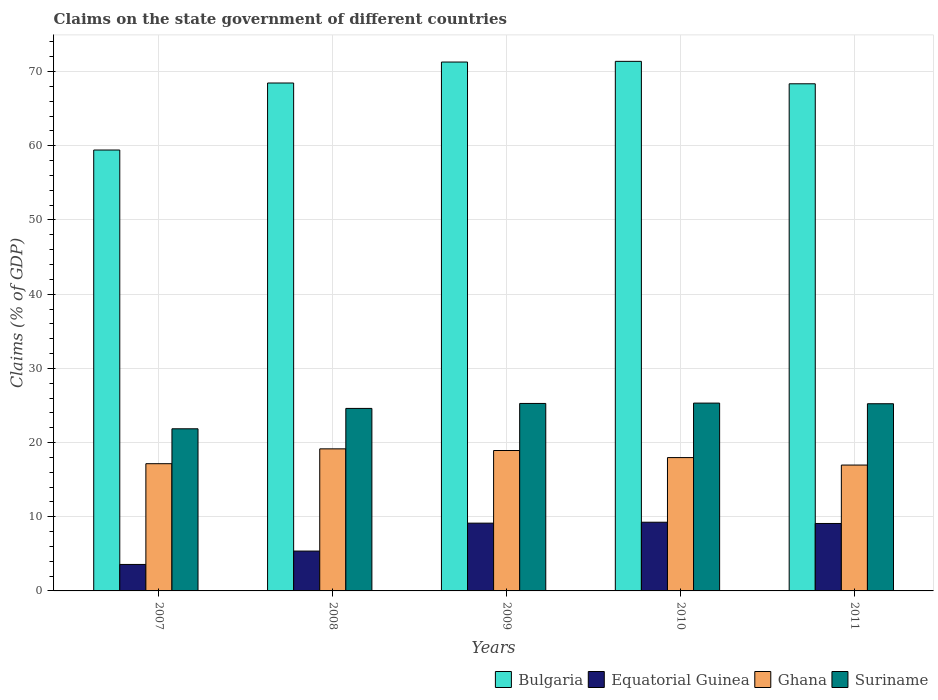How many groups of bars are there?
Your response must be concise. 5. Are the number of bars on each tick of the X-axis equal?
Provide a succinct answer. Yes. How many bars are there on the 2nd tick from the left?
Ensure brevity in your answer.  4. How many bars are there on the 3rd tick from the right?
Your answer should be very brief. 4. What is the label of the 4th group of bars from the left?
Give a very brief answer. 2010. What is the percentage of GDP claimed on the state government in Ghana in 2008?
Keep it short and to the point. 19.15. Across all years, what is the maximum percentage of GDP claimed on the state government in Suriname?
Offer a very short reply. 25.32. Across all years, what is the minimum percentage of GDP claimed on the state government in Suriname?
Your response must be concise. 21.85. What is the total percentage of GDP claimed on the state government in Bulgaria in the graph?
Offer a terse response. 338.93. What is the difference between the percentage of GDP claimed on the state government in Ghana in 2007 and that in 2010?
Your answer should be compact. -0.82. What is the difference between the percentage of GDP claimed on the state government in Ghana in 2010 and the percentage of GDP claimed on the state government in Suriname in 2009?
Your answer should be compact. -7.3. What is the average percentage of GDP claimed on the state government in Ghana per year?
Your answer should be compact. 18.03. In the year 2008, what is the difference between the percentage of GDP claimed on the state government in Equatorial Guinea and percentage of GDP claimed on the state government in Bulgaria?
Ensure brevity in your answer.  -63.09. What is the ratio of the percentage of GDP claimed on the state government in Suriname in 2007 to that in 2008?
Offer a very short reply. 0.89. Is the percentage of GDP claimed on the state government in Suriname in 2007 less than that in 2009?
Your answer should be very brief. Yes. What is the difference between the highest and the second highest percentage of GDP claimed on the state government in Ghana?
Keep it short and to the point. 0.22. What is the difference between the highest and the lowest percentage of GDP claimed on the state government in Equatorial Guinea?
Provide a succinct answer. 5.69. Is the sum of the percentage of GDP claimed on the state government in Equatorial Guinea in 2010 and 2011 greater than the maximum percentage of GDP claimed on the state government in Ghana across all years?
Provide a succinct answer. No. What does the 1st bar from the left in 2010 represents?
Ensure brevity in your answer.  Bulgaria. What does the 4th bar from the right in 2009 represents?
Ensure brevity in your answer.  Bulgaria. How many bars are there?
Ensure brevity in your answer.  20. Where does the legend appear in the graph?
Keep it short and to the point. Bottom right. What is the title of the graph?
Your answer should be compact. Claims on the state government of different countries. What is the label or title of the Y-axis?
Provide a short and direct response. Claims (% of GDP). What is the Claims (% of GDP) in Bulgaria in 2007?
Your answer should be very brief. 59.43. What is the Claims (% of GDP) of Equatorial Guinea in 2007?
Provide a succinct answer. 3.57. What is the Claims (% of GDP) of Ghana in 2007?
Ensure brevity in your answer.  17.15. What is the Claims (% of GDP) of Suriname in 2007?
Provide a short and direct response. 21.85. What is the Claims (% of GDP) in Bulgaria in 2008?
Offer a terse response. 68.46. What is the Claims (% of GDP) in Equatorial Guinea in 2008?
Offer a very short reply. 5.37. What is the Claims (% of GDP) of Ghana in 2008?
Your answer should be very brief. 19.15. What is the Claims (% of GDP) in Suriname in 2008?
Give a very brief answer. 24.6. What is the Claims (% of GDP) in Bulgaria in 2009?
Your answer should be compact. 71.29. What is the Claims (% of GDP) of Equatorial Guinea in 2009?
Your answer should be compact. 9.13. What is the Claims (% of GDP) of Ghana in 2009?
Keep it short and to the point. 18.93. What is the Claims (% of GDP) in Suriname in 2009?
Offer a terse response. 25.27. What is the Claims (% of GDP) in Bulgaria in 2010?
Keep it short and to the point. 71.38. What is the Claims (% of GDP) in Equatorial Guinea in 2010?
Offer a terse response. 9.26. What is the Claims (% of GDP) in Ghana in 2010?
Your answer should be very brief. 17.97. What is the Claims (% of GDP) in Suriname in 2010?
Give a very brief answer. 25.32. What is the Claims (% of GDP) in Bulgaria in 2011?
Give a very brief answer. 68.36. What is the Claims (% of GDP) in Equatorial Guinea in 2011?
Give a very brief answer. 9.09. What is the Claims (% of GDP) of Ghana in 2011?
Your answer should be very brief. 16.97. What is the Claims (% of GDP) in Suriname in 2011?
Give a very brief answer. 25.23. Across all years, what is the maximum Claims (% of GDP) in Bulgaria?
Give a very brief answer. 71.38. Across all years, what is the maximum Claims (% of GDP) in Equatorial Guinea?
Provide a short and direct response. 9.26. Across all years, what is the maximum Claims (% of GDP) of Ghana?
Offer a very short reply. 19.15. Across all years, what is the maximum Claims (% of GDP) of Suriname?
Your answer should be compact. 25.32. Across all years, what is the minimum Claims (% of GDP) of Bulgaria?
Ensure brevity in your answer.  59.43. Across all years, what is the minimum Claims (% of GDP) in Equatorial Guinea?
Make the answer very short. 3.57. Across all years, what is the minimum Claims (% of GDP) in Ghana?
Your answer should be compact. 16.97. Across all years, what is the minimum Claims (% of GDP) of Suriname?
Offer a terse response. 21.85. What is the total Claims (% of GDP) in Bulgaria in the graph?
Provide a succinct answer. 338.93. What is the total Claims (% of GDP) in Equatorial Guinea in the graph?
Provide a short and direct response. 36.43. What is the total Claims (% of GDP) of Ghana in the graph?
Provide a short and direct response. 90.17. What is the total Claims (% of GDP) in Suriname in the graph?
Give a very brief answer. 122.27. What is the difference between the Claims (% of GDP) in Bulgaria in 2007 and that in 2008?
Offer a terse response. -9.03. What is the difference between the Claims (% of GDP) of Equatorial Guinea in 2007 and that in 2008?
Make the answer very short. -1.8. What is the difference between the Claims (% of GDP) of Ghana in 2007 and that in 2008?
Offer a terse response. -2. What is the difference between the Claims (% of GDP) of Suriname in 2007 and that in 2008?
Offer a very short reply. -2.75. What is the difference between the Claims (% of GDP) in Bulgaria in 2007 and that in 2009?
Ensure brevity in your answer.  -11.86. What is the difference between the Claims (% of GDP) in Equatorial Guinea in 2007 and that in 2009?
Make the answer very short. -5.57. What is the difference between the Claims (% of GDP) of Ghana in 2007 and that in 2009?
Give a very brief answer. -1.78. What is the difference between the Claims (% of GDP) of Suriname in 2007 and that in 2009?
Your answer should be compact. -3.42. What is the difference between the Claims (% of GDP) of Bulgaria in 2007 and that in 2010?
Your response must be concise. -11.95. What is the difference between the Claims (% of GDP) in Equatorial Guinea in 2007 and that in 2010?
Your answer should be very brief. -5.69. What is the difference between the Claims (% of GDP) in Ghana in 2007 and that in 2010?
Keep it short and to the point. -0.82. What is the difference between the Claims (% of GDP) in Suriname in 2007 and that in 2010?
Offer a very short reply. -3.46. What is the difference between the Claims (% of GDP) of Bulgaria in 2007 and that in 2011?
Offer a terse response. -8.93. What is the difference between the Claims (% of GDP) in Equatorial Guinea in 2007 and that in 2011?
Provide a short and direct response. -5.52. What is the difference between the Claims (% of GDP) in Ghana in 2007 and that in 2011?
Your answer should be very brief. 0.18. What is the difference between the Claims (% of GDP) of Suriname in 2007 and that in 2011?
Make the answer very short. -3.38. What is the difference between the Claims (% of GDP) of Bulgaria in 2008 and that in 2009?
Offer a terse response. -2.83. What is the difference between the Claims (% of GDP) of Equatorial Guinea in 2008 and that in 2009?
Provide a short and direct response. -3.76. What is the difference between the Claims (% of GDP) of Ghana in 2008 and that in 2009?
Your answer should be compact. 0.22. What is the difference between the Claims (% of GDP) in Suriname in 2008 and that in 2009?
Offer a terse response. -0.67. What is the difference between the Claims (% of GDP) of Bulgaria in 2008 and that in 2010?
Your answer should be compact. -2.92. What is the difference between the Claims (% of GDP) in Equatorial Guinea in 2008 and that in 2010?
Offer a terse response. -3.89. What is the difference between the Claims (% of GDP) in Ghana in 2008 and that in 2010?
Provide a succinct answer. 1.18. What is the difference between the Claims (% of GDP) of Suriname in 2008 and that in 2010?
Your answer should be very brief. -0.72. What is the difference between the Claims (% of GDP) of Bulgaria in 2008 and that in 2011?
Your answer should be very brief. 0.1. What is the difference between the Claims (% of GDP) in Equatorial Guinea in 2008 and that in 2011?
Your answer should be very brief. -3.72. What is the difference between the Claims (% of GDP) in Ghana in 2008 and that in 2011?
Keep it short and to the point. 2.18. What is the difference between the Claims (% of GDP) in Suriname in 2008 and that in 2011?
Your answer should be compact. -0.63. What is the difference between the Claims (% of GDP) in Bulgaria in 2009 and that in 2010?
Give a very brief answer. -0.09. What is the difference between the Claims (% of GDP) in Equatorial Guinea in 2009 and that in 2010?
Your answer should be compact. -0.13. What is the difference between the Claims (% of GDP) in Ghana in 2009 and that in 2010?
Keep it short and to the point. 0.95. What is the difference between the Claims (% of GDP) of Suriname in 2009 and that in 2010?
Your answer should be compact. -0.05. What is the difference between the Claims (% of GDP) in Bulgaria in 2009 and that in 2011?
Make the answer very short. 2.93. What is the difference between the Claims (% of GDP) of Equatorial Guinea in 2009 and that in 2011?
Provide a succinct answer. 0.04. What is the difference between the Claims (% of GDP) in Ghana in 2009 and that in 2011?
Give a very brief answer. 1.96. What is the difference between the Claims (% of GDP) in Suriname in 2009 and that in 2011?
Provide a succinct answer. 0.04. What is the difference between the Claims (% of GDP) of Bulgaria in 2010 and that in 2011?
Give a very brief answer. 3.02. What is the difference between the Claims (% of GDP) of Equatorial Guinea in 2010 and that in 2011?
Your answer should be very brief. 0.17. What is the difference between the Claims (% of GDP) in Suriname in 2010 and that in 2011?
Offer a terse response. 0.09. What is the difference between the Claims (% of GDP) in Bulgaria in 2007 and the Claims (% of GDP) in Equatorial Guinea in 2008?
Keep it short and to the point. 54.06. What is the difference between the Claims (% of GDP) in Bulgaria in 2007 and the Claims (% of GDP) in Ghana in 2008?
Your answer should be compact. 40.28. What is the difference between the Claims (% of GDP) in Bulgaria in 2007 and the Claims (% of GDP) in Suriname in 2008?
Your response must be concise. 34.83. What is the difference between the Claims (% of GDP) of Equatorial Guinea in 2007 and the Claims (% of GDP) of Ghana in 2008?
Your response must be concise. -15.58. What is the difference between the Claims (% of GDP) of Equatorial Guinea in 2007 and the Claims (% of GDP) of Suriname in 2008?
Make the answer very short. -21.03. What is the difference between the Claims (% of GDP) in Ghana in 2007 and the Claims (% of GDP) in Suriname in 2008?
Ensure brevity in your answer.  -7.45. What is the difference between the Claims (% of GDP) of Bulgaria in 2007 and the Claims (% of GDP) of Equatorial Guinea in 2009?
Your answer should be compact. 50.3. What is the difference between the Claims (% of GDP) of Bulgaria in 2007 and the Claims (% of GDP) of Ghana in 2009?
Offer a terse response. 40.5. What is the difference between the Claims (% of GDP) of Bulgaria in 2007 and the Claims (% of GDP) of Suriname in 2009?
Ensure brevity in your answer.  34.16. What is the difference between the Claims (% of GDP) of Equatorial Guinea in 2007 and the Claims (% of GDP) of Ghana in 2009?
Your answer should be compact. -15.36. What is the difference between the Claims (% of GDP) in Equatorial Guinea in 2007 and the Claims (% of GDP) in Suriname in 2009?
Provide a succinct answer. -21.7. What is the difference between the Claims (% of GDP) of Ghana in 2007 and the Claims (% of GDP) of Suriname in 2009?
Your answer should be compact. -8.12. What is the difference between the Claims (% of GDP) in Bulgaria in 2007 and the Claims (% of GDP) in Equatorial Guinea in 2010?
Offer a very short reply. 50.17. What is the difference between the Claims (% of GDP) in Bulgaria in 2007 and the Claims (% of GDP) in Ghana in 2010?
Provide a short and direct response. 41.46. What is the difference between the Claims (% of GDP) in Bulgaria in 2007 and the Claims (% of GDP) in Suriname in 2010?
Your response must be concise. 34.11. What is the difference between the Claims (% of GDP) of Equatorial Guinea in 2007 and the Claims (% of GDP) of Ghana in 2010?
Offer a terse response. -14.4. What is the difference between the Claims (% of GDP) in Equatorial Guinea in 2007 and the Claims (% of GDP) in Suriname in 2010?
Provide a short and direct response. -21.75. What is the difference between the Claims (% of GDP) in Ghana in 2007 and the Claims (% of GDP) in Suriname in 2010?
Ensure brevity in your answer.  -8.17. What is the difference between the Claims (% of GDP) of Bulgaria in 2007 and the Claims (% of GDP) of Equatorial Guinea in 2011?
Offer a terse response. 50.34. What is the difference between the Claims (% of GDP) in Bulgaria in 2007 and the Claims (% of GDP) in Ghana in 2011?
Offer a very short reply. 42.46. What is the difference between the Claims (% of GDP) in Bulgaria in 2007 and the Claims (% of GDP) in Suriname in 2011?
Provide a short and direct response. 34.2. What is the difference between the Claims (% of GDP) in Equatorial Guinea in 2007 and the Claims (% of GDP) in Ghana in 2011?
Ensure brevity in your answer.  -13.4. What is the difference between the Claims (% of GDP) of Equatorial Guinea in 2007 and the Claims (% of GDP) of Suriname in 2011?
Provide a short and direct response. -21.66. What is the difference between the Claims (% of GDP) in Ghana in 2007 and the Claims (% of GDP) in Suriname in 2011?
Make the answer very short. -8.08. What is the difference between the Claims (% of GDP) of Bulgaria in 2008 and the Claims (% of GDP) of Equatorial Guinea in 2009?
Offer a very short reply. 59.33. What is the difference between the Claims (% of GDP) of Bulgaria in 2008 and the Claims (% of GDP) of Ghana in 2009?
Offer a terse response. 49.54. What is the difference between the Claims (% of GDP) of Bulgaria in 2008 and the Claims (% of GDP) of Suriname in 2009?
Offer a very short reply. 43.19. What is the difference between the Claims (% of GDP) in Equatorial Guinea in 2008 and the Claims (% of GDP) in Ghana in 2009?
Your response must be concise. -13.56. What is the difference between the Claims (% of GDP) in Equatorial Guinea in 2008 and the Claims (% of GDP) in Suriname in 2009?
Ensure brevity in your answer.  -19.9. What is the difference between the Claims (% of GDP) in Ghana in 2008 and the Claims (% of GDP) in Suriname in 2009?
Your response must be concise. -6.12. What is the difference between the Claims (% of GDP) of Bulgaria in 2008 and the Claims (% of GDP) of Equatorial Guinea in 2010?
Provide a succinct answer. 59.2. What is the difference between the Claims (% of GDP) in Bulgaria in 2008 and the Claims (% of GDP) in Ghana in 2010?
Provide a short and direct response. 50.49. What is the difference between the Claims (% of GDP) in Bulgaria in 2008 and the Claims (% of GDP) in Suriname in 2010?
Your answer should be very brief. 43.15. What is the difference between the Claims (% of GDP) of Equatorial Guinea in 2008 and the Claims (% of GDP) of Ghana in 2010?
Give a very brief answer. -12.6. What is the difference between the Claims (% of GDP) in Equatorial Guinea in 2008 and the Claims (% of GDP) in Suriname in 2010?
Ensure brevity in your answer.  -19.95. What is the difference between the Claims (% of GDP) of Ghana in 2008 and the Claims (% of GDP) of Suriname in 2010?
Ensure brevity in your answer.  -6.17. What is the difference between the Claims (% of GDP) of Bulgaria in 2008 and the Claims (% of GDP) of Equatorial Guinea in 2011?
Ensure brevity in your answer.  59.37. What is the difference between the Claims (% of GDP) of Bulgaria in 2008 and the Claims (% of GDP) of Ghana in 2011?
Offer a terse response. 51.5. What is the difference between the Claims (% of GDP) in Bulgaria in 2008 and the Claims (% of GDP) in Suriname in 2011?
Offer a very short reply. 43.23. What is the difference between the Claims (% of GDP) of Equatorial Guinea in 2008 and the Claims (% of GDP) of Ghana in 2011?
Your answer should be very brief. -11.6. What is the difference between the Claims (% of GDP) in Equatorial Guinea in 2008 and the Claims (% of GDP) in Suriname in 2011?
Your answer should be very brief. -19.86. What is the difference between the Claims (% of GDP) in Ghana in 2008 and the Claims (% of GDP) in Suriname in 2011?
Offer a very short reply. -6.08. What is the difference between the Claims (% of GDP) in Bulgaria in 2009 and the Claims (% of GDP) in Equatorial Guinea in 2010?
Provide a short and direct response. 62.03. What is the difference between the Claims (% of GDP) of Bulgaria in 2009 and the Claims (% of GDP) of Ghana in 2010?
Offer a very short reply. 53.32. What is the difference between the Claims (% of GDP) of Bulgaria in 2009 and the Claims (% of GDP) of Suriname in 2010?
Your answer should be very brief. 45.97. What is the difference between the Claims (% of GDP) in Equatorial Guinea in 2009 and the Claims (% of GDP) in Ghana in 2010?
Give a very brief answer. -8.84. What is the difference between the Claims (% of GDP) in Equatorial Guinea in 2009 and the Claims (% of GDP) in Suriname in 2010?
Keep it short and to the point. -16.18. What is the difference between the Claims (% of GDP) in Ghana in 2009 and the Claims (% of GDP) in Suriname in 2010?
Provide a succinct answer. -6.39. What is the difference between the Claims (% of GDP) in Bulgaria in 2009 and the Claims (% of GDP) in Equatorial Guinea in 2011?
Your response must be concise. 62.2. What is the difference between the Claims (% of GDP) of Bulgaria in 2009 and the Claims (% of GDP) of Ghana in 2011?
Offer a very short reply. 54.32. What is the difference between the Claims (% of GDP) of Bulgaria in 2009 and the Claims (% of GDP) of Suriname in 2011?
Your answer should be compact. 46.06. What is the difference between the Claims (% of GDP) in Equatorial Guinea in 2009 and the Claims (% of GDP) in Ghana in 2011?
Give a very brief answer. -7.83. What is the difference between the Claims (% of GDP) of Equatorial Guinea in 2009 and the Claims (% of GDP) of Suriname in 2011?
Keep it short and to the point. -16.1. What is the difference between the Claims (% of GDP) in Ghana in 2009 and the Claims (% of GDP) in Suriname in 2011?
Offer a very short reply. -6.3. What is the difference between the Claims (% of GDP) in Bulgaria in 2010 and the Claims (% of GDP) in Equatorial Guinea in 2011?
Your response must be concise. 62.29. What is the difference between the Claims (% of GDP) of Bulgaria in 2010 and the Claims (% of GDP) of Ghana in 2011?
Keep it short and to the point. 54.42. What is the difference between the Claims (% of GDP) of Bulgaria in 2010 and the Claims (% of GDP) of Suriname in 2011?
Provide a succinct answer. 46.15. What is the difference between the Claims (% of GDP) in Equatorial Guinea in 2010 and the Claims (% of GDP) in Ghana in 2011?
Your answer should be very brief. -7.71. What is the difference between the Claims (% of GDP) in Equatorial Guinea in 2010 and the Claims (% of GDP) in Suriname in 2011?
Provide a short and direct response. -15.97. What is the difference between the Claims (% of GDP) in Ghana in 2010 and the Claims (% of GDP) in Suriname in 2011?
Offer a terse response. -7.26. What is the average Claims (% of GDP) in Bulgaria per year?
Offer a terse response. 67.79. What is the average Claims (% of GDP) of Equatorial Guinea per year?
Your response must be concise. 7.29. What is the average Claims (% of GDP) of Ghana per year?
Your answer should be very brief. 18.03. What is the average Claims (% of GDP) of Suriname per year?
Your answer should be compact. 24.45. In the year 2007, what is the difference between the Claims (% of GDP) in Bulgaria and Claims (% of GDP) in Equatorial Guinea?
Offer a very short reply. 55.86. In the year 2007, what is the difference between the Claims (% of GDP) in Bulgaria and Claims (% of GDP) in Ghana?
Your response must be concise. 42.28. In the year 2007, what is the difference between the Claims (% of GDP) in Bulgaria and Claims (% of GDP) in Suriname?
Your answer should be very brief. 37.58. In the year 2007, what is the difference between the Claims (% of GDP) in Equatorial Guinea and Claims (% of GDP) in Ghana?
Your response must be concise. -13.58. In the year 2007, what is the difference between the Claims (% of GDP) of Equatorial Guinea and Claims (% of GDP) of Suriname?
Make the answer very short. -18.29. In the year 2007, what is the difference between the Claims (% of GDP) in Ghana and Claims (% of GDP) in Suriname?
Your response must be concise. -4.7. In the year 2008, what is the difference between the Claims (% of GDP) of Bulgaria and Claims (% of GDP) of Equatorial Guinea?
Make the answer very short. 63.09. In the year 2008, what is the difference between the Claims (% of GDP) in Bulgaria and Claims (% of GDP) in Ghana?
Ensure brevity in your answer.  49.31. In the year 2008, what is the difference between the Claims (% of GDP) of Bulgaria and Claims (% of GDP) of Suriname?
Your answer should be compact. 43.86. In the year 2008, what is the difference between the Claims (% of GDP) in Equatorial Guinea and Claims (% of GDP) in Ghana?
Your response must be concise. -13.78. In the year 2008, what is the difference between the Claims (% of GDP) of Equatorial Guinea and Claims (% of GDP) of Suriname?
Provide a succinct answer. -19.23. In the year 2008, what is the difference between the Claims (% of GDP) in Ghana and Claims (% of GDP) in Suriname?
Provide a succinct answer. -5.45. In the year 2009, what is the difference between the Claims (% of GDP) of Bulgaria and Claims (% of GDP) of Equatorial Guinea?
Provide a short and direct response. 62.16. In the year 2009, what is the difference between the Claims (% of GDP) of Bulgaria and Claims (% of GDP) of Ghana?
Offer a terse response. 52.36. In the year 2009, what is the difference between the Claims (% of GDP) in Bulgaria and Claims (% of GDP) in Suriname?
Your response must be concise. 46.02. In the year 2009, what is the difference between the Claims (% of GDP) in Equatorial Guinea and Claims (% of GDP) in Ghana?
Your response must be concise. -9.79. In the year 2009, what is the difference between the Claims (% of GDP) in Equatorial Guinea and Claims (% of GDP) in Suriname?
Offer a terse response. -16.14. In the year 2009, what is the difference between the Claims (% of GDP) of Ghana and Claims (% of GDP) of Suriname?
Give a very brief answer. -6.34. In the year 2010, what is the difference between the Claims (% of GDP) of Bulgaria and Claims (% of GDP) of Equatorial Guinea?
Give a very brief answer. 62.12. In the year 2010, what is the difference between the Claims (% of GDP) of Bulgaria and Claims (% of GDP) of Ghana?
Offer a terse response. 53.41. In the year 2010, what is the difference between the Claims (% of GDP) in Bulgaria and Claims (% of GDP) in Suriname?
Your response must be concise. 46.07. In the year 2010, what is the difference between the Claims (% of GDP) in Equatorial Guinea and Claims (% of GDP) in Ghana?
Ensure brevity in your answer.  -8.71. In the year 2010, what is the difference between the Claims (% of GDP) of Equatorial Guinea and Claims (% of GDP) of Suriname?
Offer a terse response. -16.06. In the year 2010, what is the difference between the Claims (% of GDP) in Ghana and Claims (% of GDP) in Suriname?
Provide a short and direct response. -7.34. In the year 2011, what is the difference between the Claims (% of GDP) of Bulgaria and Claims (% of GDP) of Equatorial Guinea?
Provide a succinct answer. 59.27. In the year 2011, what is the difference between the Claims (% of GDP) of Bulgaria and Claims (% of GDP) of Ghana?
Provide a succinct answer. 51.39. In the year 2011, what is the difference between the Claims (% of GDP) in Bulgaria and Claims (% of GDP) in Suriname?
Ensure brevity in your answer.  43.13. In the year 2011, what is the difference between the Claims (% of GDP) of Equatorial Guinea and Claims (% of GDP) of Ghana?
Your answer should be very brief. -7.88. In the year 2011, what is the difference between the Claims (% of GDP) of Equatorial Guinea and Claims (% of GDP) of Suriname?
Provide a succinct answer. -16.14. In the year 2011, what is the difference between the Claims (% of GDP) in Ghana and Claims (% of GDP) in Suriname?
Give a very brief answer. -8.26. What is the ratio of the Claims (% of GDP) in Bulgaria in 2007 to that in 2008?
Ensure brevity in your answer.  0.87. What is the ratio of the Claims (% of GDP) of Equatorial Guinea in 2007 to that in 2008?
Your answer should be very brief. 0.66. What is the ratio of the Claims (% of GDP) of Ghana in 2007 to that in 2008?
Offer a terse response. 0.9. What is the ratio of the Claims (% of GDP) in Suriname in 2007 to that in 2008?
Provide a short and direct response. 0.89. What is the ratio of the Claims (% of GDP) in Bulgaria in 2007 to that in 2009?
Make the answer very short. 0.83. What is the ratio of the Claims (% of GDP) of Equatorial Guinea in 2007 to that in 2009?
Offer a very short reply. 0.39. What is the ratio of the Claims (% of GDP) in Ghana in 2007 to that in 2009?
Offer a very short reply. 0.91. What is the ratio of the Claims (% of GDP) in Suriname in 2007 to that in 2009?
Ensure brevity in your answer.  0.86. What is the ratio of the Claims (% of GDP) of Bulgaria in 2007 to that in 2010?
Your answer should be very brief. 0.83. What is the ratio of the Claims (% of GDP) of Equatorial Guinea in 2007 to that in 2010?
Ensure brevity in your answer.  0.39. What is the ratio of the Claims (% of GDP) of Ghana in 2007 to that in 2010?
Keep it short and to the point. 0.95. What is the ratio of the Claims (% of GDP) of Suriname in 2007 to that in 2010?
Give a very brief answer. 0.86. What is the ratio of the Claims (% of GDP) of Bulgaria in 2007 to that in 2011?
Offer a terse response. 0.87. What is the ratio of the Claims (% of GDP) of Equatorial Guinea in 2007 to that in 2011?
Your answer should be very brief. 0.39. What is the ratio of the Claims (% of GDP) of Ghana in 2007 to that in 2011?
Provide a short and direct response. 1.01. What is the ratio of the Claims (% of GDP) of Suriname in 2007 to that in 2011?
Offer a terse response. 0.87. What is the ratio of the Claims (% of GDP) in Bulgaria in 2008 to that in 2009?
Provide a short and direct response. 0.96. What is the ratio of the Claims (% of GDP) in Equatorial Guinea in 2008 to that in 2009?
Give a very brief answer. 0.59. What is the ratio of the Claims (% of GDP) in Ghana in 2008 to that in 2009?
Make the answer very short. 1.01. What is the ratio of the Claims (% of GDP) of Suriname in 2008 to that in 2009?
Keep it short and to the point. 0.97. What is the ratio of the Claims (% of GDP) of Bulgaria in 2008 to that in 2010?
Ensure brevity in your answer.  0.96. What is the ratio of the Claims (% of GDP) in Equatorial Guinea in 2008 to that in 2010?
Ensure brevity in your answer.  0.58. What is the ratio of the Claims (% of GDP) in Ghana in 2008 to that in 2010?
Keep it short and to the point. 1.07. What is the ratio of the Claims (% of GDP) of Suriname in 2008 to that in 2010?
Give a very brief answer. 0.97. What is the ratio of the Claims (% of GDP) in Bulgaria in 2008 to that in 2011?
Your response must be concise. 1. What is the ratio of the Claims (% of GDP) of Equatorial Guinea in 2008 to that in 2011?
Provide a succinct answer. 0.59. What is the ratio of the Claims (% of GDP) in Ghana in 2008 to that in 2011?
Keep it short and to the point. 1.13. What is the ratio of the Claims (% of GDP) in Suriname in 2008 to that in 2011?
Keep it short and to the point. 0.98. What is the ratio of the Claims (% of GDP) of Equatorial Guinea in 2009 to that in 2010?
Offer a very short reply. 0.99. What is the ratio of the Claims (% of GDP) in Ghana in 2009 to that in 2010?
Give a very brief answer. 1.05. What is the ratio of the Claims (% of GDP) in Suriname in 2009 to that in 2010?
Offer a very short reply. 1. What is the ratio of the Claims (% of GDP) of Bulgaria in 2009 to that in 2011?
Offer a terse response. 1.04. What is the ratio of the Claims (% of GDP) in Equatorial Guinea in 2009 to that in 2011?
Your answer should be compact. 1. What is the ratio of the Claims (% of GDP) in Ghana in 2009 to that in 2011?
Your answer should be compact. 1.12. What is the ratio of the Claims (% of GDP) in Bulgaria in 2010 to that in 2011?
Make the answer very short. 1.04. What is the ratio of the Claims (% of GDP) of Equatorial Guinea in 2010 to that in 2011?
Your response must be concise. 1.02. What is the ratio of the Claims (% of GDP) of Ghana in 2010 to that in 2011?
Provide a succinct answer. 1.06. What is the ratio of the Claims (% of GDP) in Suriname in 2010 to that in 2011?
Make the answer very short. 1. What is the difference between the highest and the second highest Claims (% of GDP) in Bulgaria?
Give a very brief answer. 0.09. What is the difference between the highest and the second highest Claims (% of GDP) in Equatorial Guinea?
Give a very brief answer. 0.13. What is the difference between the highest and the second highest Claims (% of GDP) in Ghana?
Offer a very short reply. 0.22. What is the difference between the highest and the second highest Claims (% of GDP) in Suriname?
Give a very brief answer. 0.05. What is the difference between the highest and the lowest Claims (% of GDP) in Bulgaria?
Your response must be concise. 11.95. What is the difference between the highest and the lowest Claims (% of GDP) of Equatorial Guinea?
Offer a terse response. 5.69. What is the difference between the highest and the lowest Claims (% of GDP) of Ghana?
Provide a succinct answer. 2.18. What is the difference between the highest and the lowest Claims (% of GDP) in Suriname?
Make the answer very short. 3.46. 